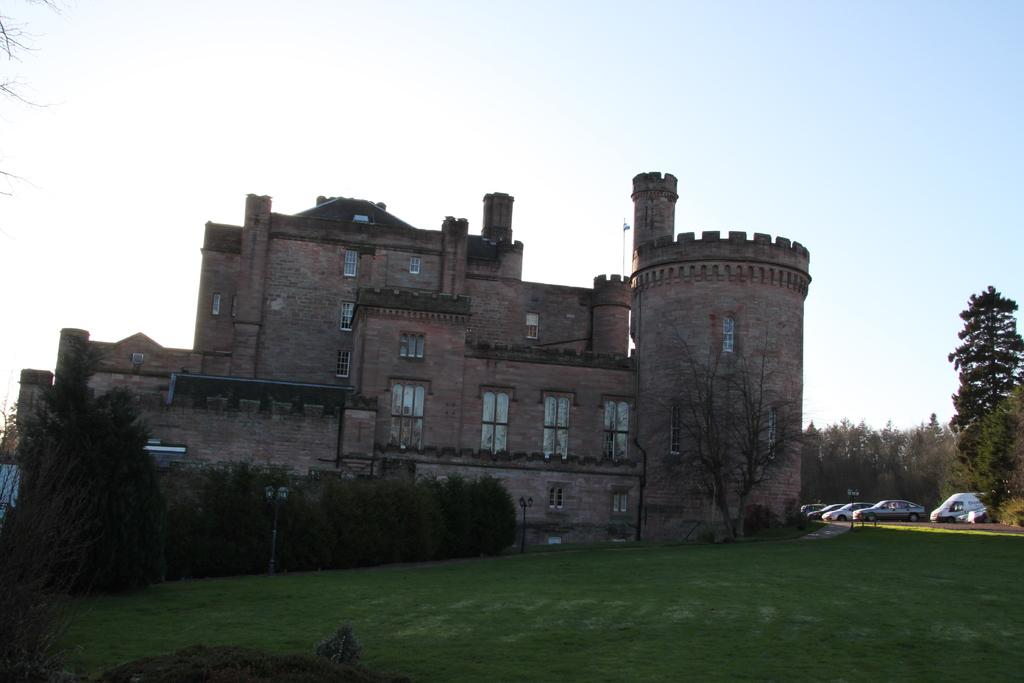What type of ground surface is visible in the image? There is grass on the ground in the image. What can be seen in the background of the image? There are plants, a building with glass windows, vehicles, and trees in the background. What is the color of the sky in the image? The sky is blue in the image. Can you see a rat swimming in the ocean in the image? There is no rat or ocean present in the image. 